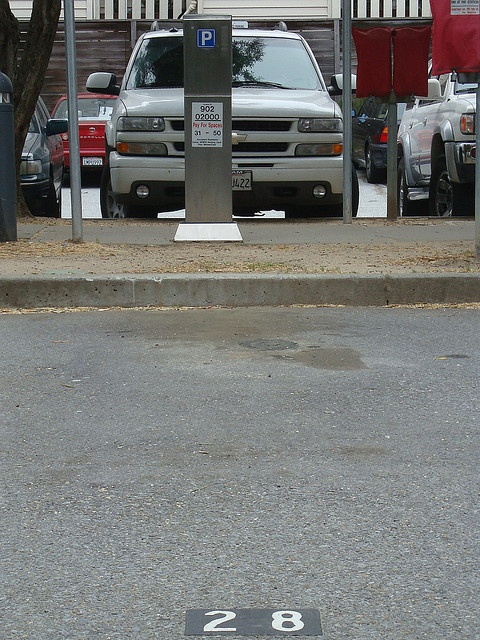Describe the objects in this image and their specific colors. I can see car in black, gray, darkgray, and lightgray tones, car in black, darkgray, gray, and lightgray tones, car in black, gray, darkgray, and maroon tones, parking meter in black, gray, navy, and darkgray tones, and car in black, purple, and darkgray tones in this image. 